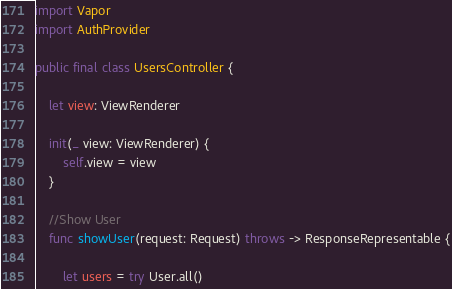<code> <loc_0><loc_0><loc_500><loc_500><_Swift_>import Vapor
import AuthProvider

public final class UsersController {
    
    let view: ViewRenderer
    
    init(_ view: ViewRenderer) {
        self.view = view
    }
   
    //Show User
    func showUser(request: Request) throws -> ResponseRepresentable {
        
        let users = try User.all()</code> 